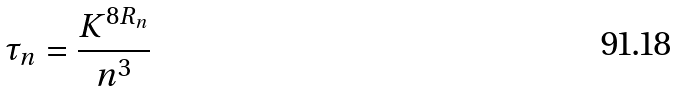Convert formula to latex. <formula><loc_0><loc_0><loc_500><loc_500>\tau _ { n } = \frac { K ^ { 8 R _ { n } } } { n ^ { 3 } }</formula> 